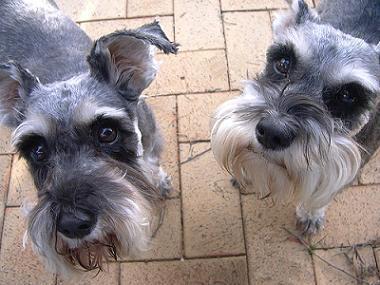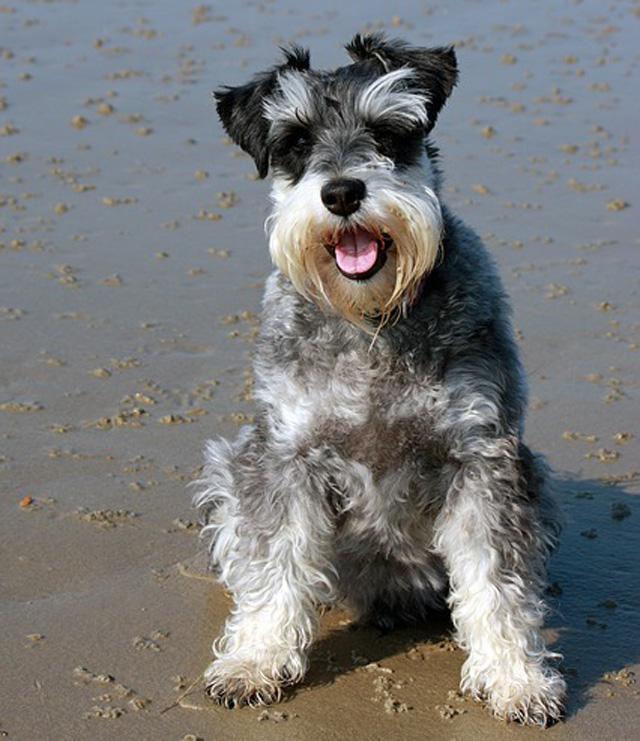The first image is the image on the left, the second image is the image on the right. Given the left and right images, does the statement "There are two lighter colored dogs and two darker colored dogs." hold true? Answer yes or no. No. 